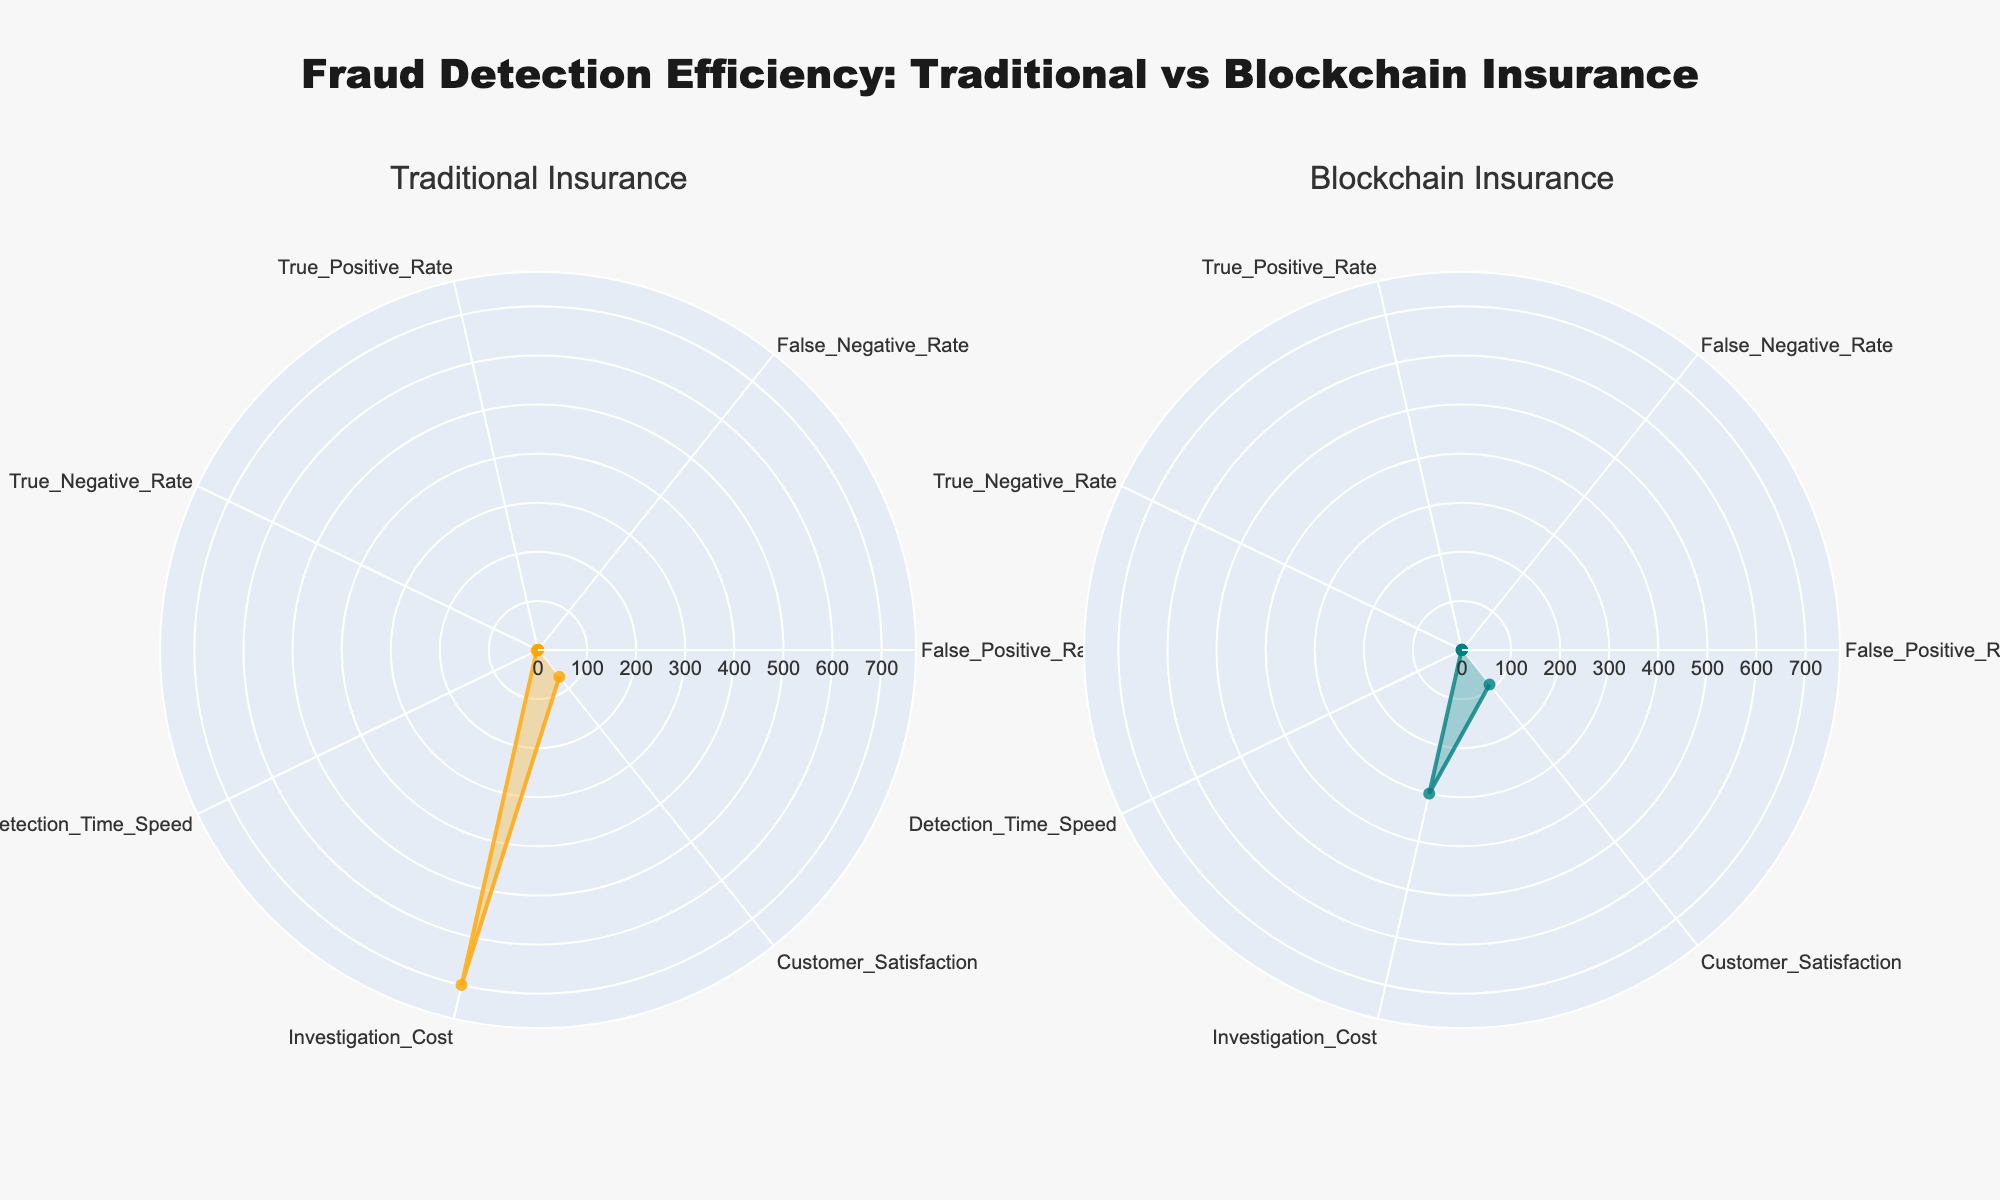What is the title of the figure? The title is usually located at the top of the figure. In this case, it reads, "Fraud Detection Efficiency: Traditional vs Blockchain Insurance"
Answer: Fraud Detection Efficiency: Traditional vs Blockchain Insurance Which insurance type has a lower false positive rate? By comparing the values along the "False Positive Rate" axis in both subplots, we see that Blockchain Insurance has a lower rate.
Answer: Blockchain Insurance How do customer satisfaction rates compare between traditional and blockchain insurance? By examining the "Customer Satisfaction" axis on both subplots, Blockchain Insurance has a higher satisfaction rate (90) compared to Traditional Insurance (70).
Answer: Blockchain Insurance Which insurance type has a higher true negative rate? Comparing the true negative rates on both subplots reveals that Blockchain Insurance has a higher true negative rate (0.85) than Traditional Insurance (0.50).
Answer: Blockchain Insurance What is the investigation cost for blockchain insurance? Look along the "Investigation Cost" axis in the Blockchain Insurance subplot; it shows a value of 300.
Answer: 300 How does the speed of detection time compare between the two types of insurance? By comparing the values along the "Detection Time Speed" axis in both subplots, it's clear that Blockchain Insurance has a faster detection time (1) compared to Traditional Insurance (3).
Answer: Blockchain Insurance What is the difference in the true positive rate between traditional and blockchain insurance? By looking at the "True Positive Rate" on both plots, Traditional Insurance has 0.70, and Blockchain Insurance has 0.90. The difference is 0.90 - 0.70 = 0.20.
Answer: 0.20 Which insurance type performs better in terms of false negative rate? The false negative rate for Traditional Insurance is 0.30 and for Blockchain Insurance is 0.10, indicating Blockchain Insurance performs better.
Answer: Blockchain Insurance How many categories are being compared in the figure? Counting the different labeled axes in either subplot, we see there are 7 categories: False Positive Rate, False Negative Rate, True Positive Rate, True Negative Rate, Detection Time Speed, Investigation Cost, and Customer Satisfaction.
Answer: 7 In which category does blockchain insurance show the most significant improvement over traditional insurance? By inspecting the relative distances in values for each category, the most significant improvement is in the "True Negative Rate" where Blockchain Insurance (0.85) is better than Traditional Insurance (0.50).
Answer: True Negative Rate 